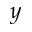Convert formula to latex. <formula><loc_0><loc_0><loc_500><loc_500>y</formula> 